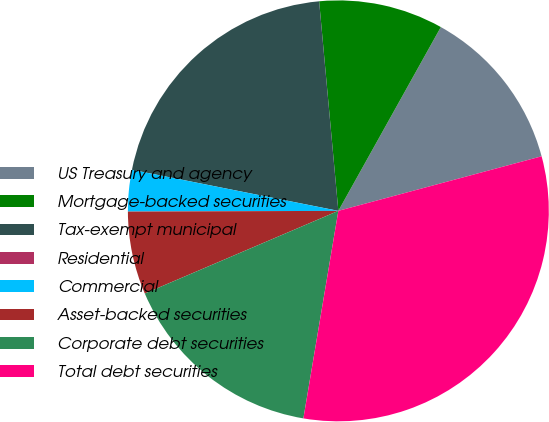Convert chart to OTSL. <chart><loc_0><loc_0><loc_500><loc_500><pie_chart><fcel>US Treasury and agency<fcel>Mortgage-backed securities<fcel>Tax-exempt municipal<fcel>Residential<fcel>Commercial<fcel>Asset-backed securities<fcel>Corporate debt securities<fcel>Total debt securities<nl><fcel>12.73%<fcel>9.55%<fcel>20.42%<fcel>0.0%<fcel>3.18%<fcel>6.37%<fcel>15.92%<fcel>31.83%<nl></chart> 